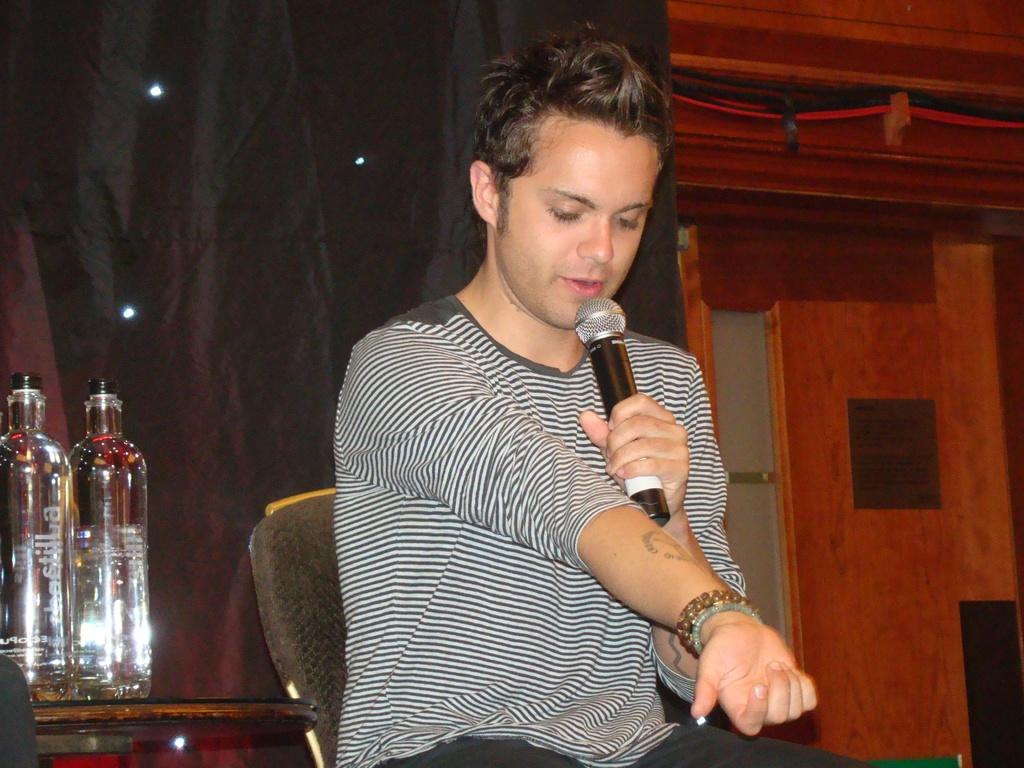What is the main subject of the image? There is a man in the image. What is the man doing in the image? The man is sitting on a chair and holding a microphone in his hand. What else can be seen in the image besides the man? There is a table in the image, and two bottles are placed on the table. Can you describe the river flowing behind the man in the image? There is no river present in the image; it only shows a man sitting on a chair, holding a microphone, and a table with two bottles on it. 